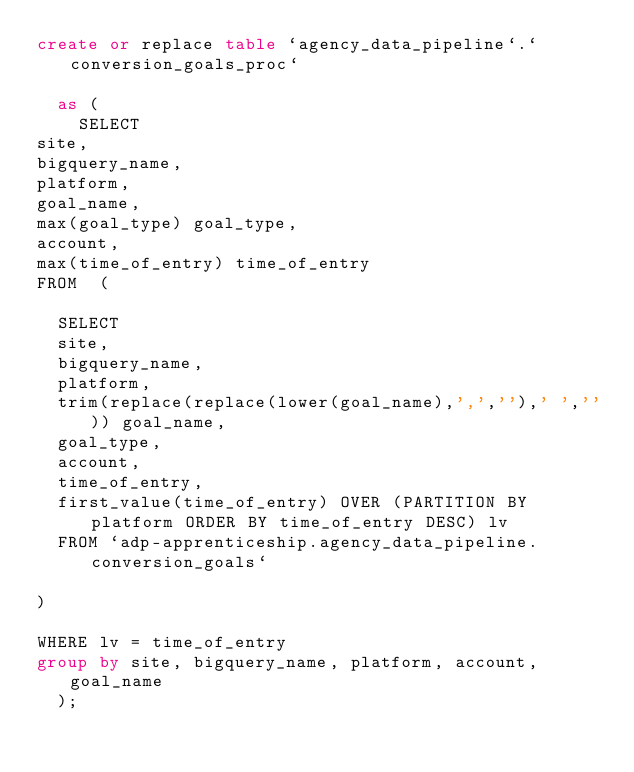Convert code to text. <code><loc_0><loc_0><loc_500><loc_500><_SQL_>create or replace table `agency_data_pipeline`.`conversion_goals_proc`
  
  as (
    SELECT 
site,
bigquery_name,
platform,
goal_name,
max(goal_type) goal_type,
account,
max(time_of_entry) time_of_entry
FROM  ( 

	SELECT  
	site,
	bigquery_name,
	platform,
	trim(replace(replace(lower(goal_name),',',''),' ','')) goal_name,
	goal_type,
	account,
	time_of_entry,
	first_value(time_of_entry) OVER (PARTITION BY platform ORDER BY time_of_entry DESC) lv
	FROM `adp-apprenticeship.agency_data_pipeline.conversion_goals` 

) 

WHERE lv = time_of_entry
group by site, bigquery_name, platform, account, goal_name
  );

    </code> 